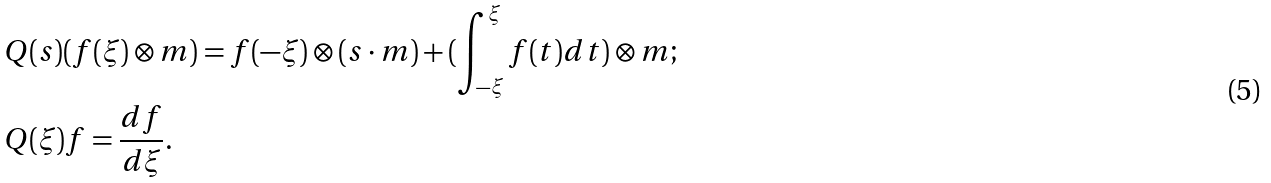Convert formula to latex. <formula><loc_0><loc_0><loc_500><loc_500>& Q ( s ) ( f ( \xi ) \otimes m ) = f ( - \xi ) \otimes ( s \cdot m ) + ( \int _ { - \xi } ^ { \xi } f ( t ) d t ) \otimes m ; \\ & Q ( \xi ) f = \frac { d f } { d \xi } .</formula> 